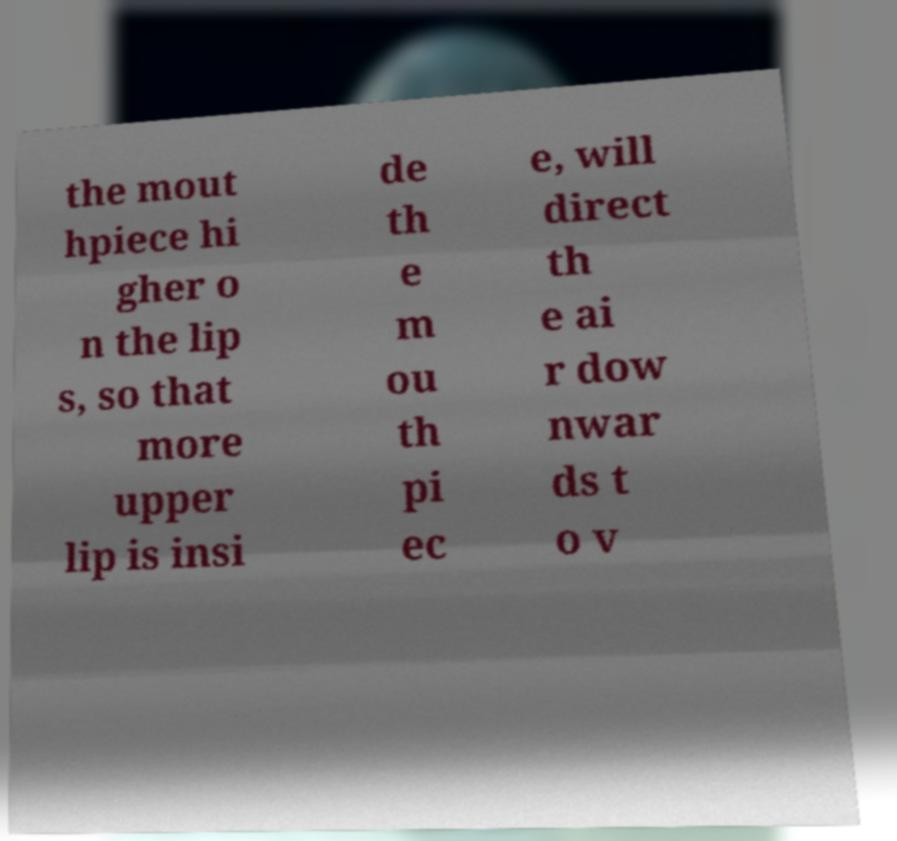Could you assist in decoding the text presented in this image and type it out clearly? the mout hpiece hi gher o n the lip s, so that more upper lip is insi de th e m ou th pi ec e, will direct th e ai r dow nwar ds t o v 